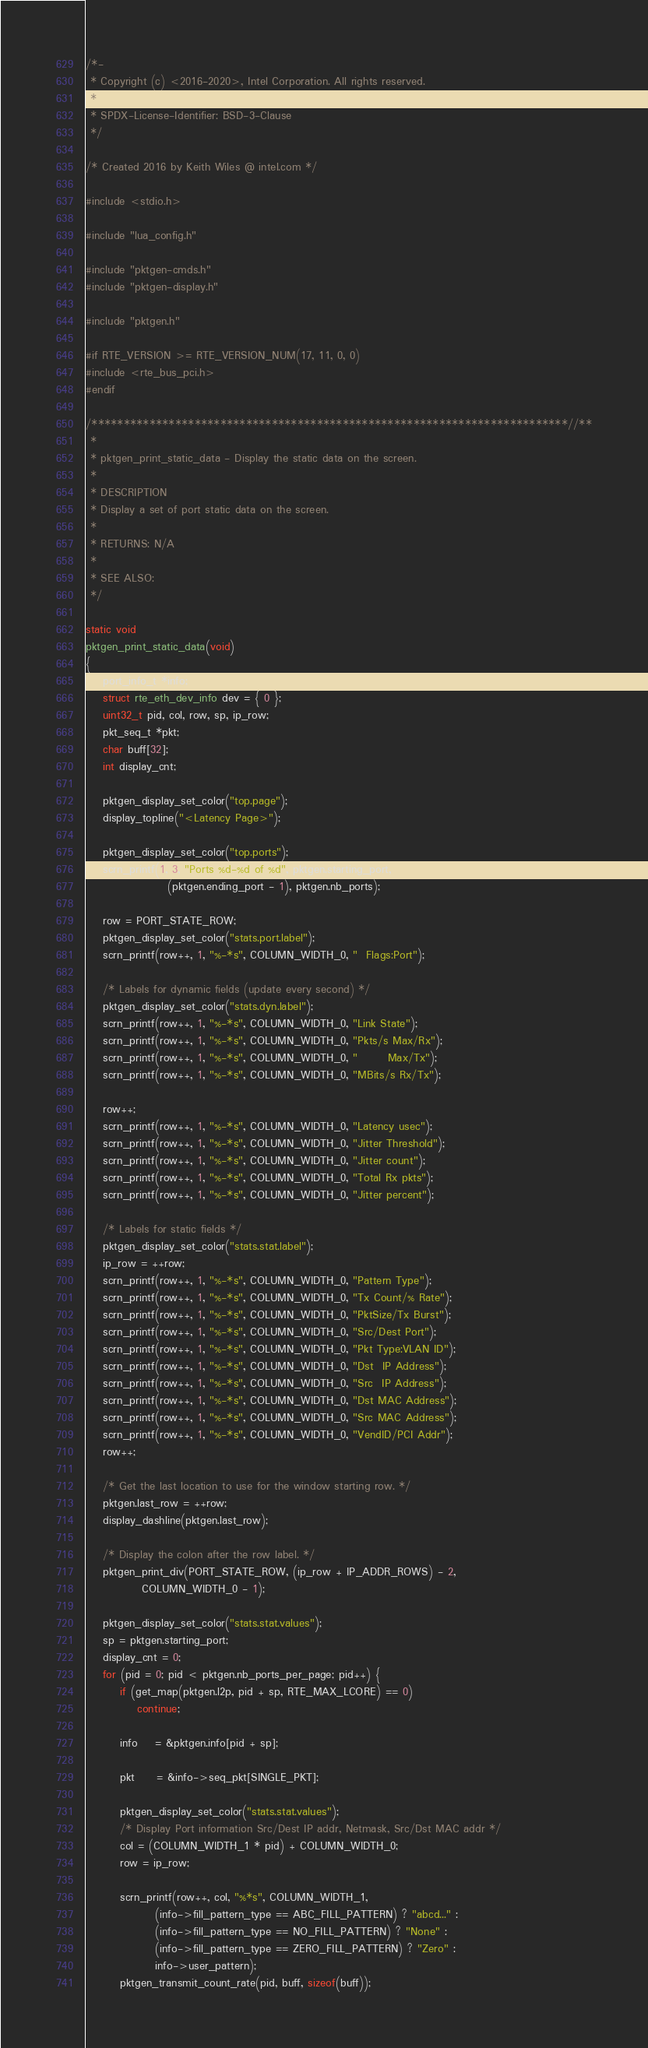<code> <loc_0><loc_0><loc_500><loc_500><_C_>/*-
 * Copyright (c) <2016-2020>, Intel Corporation. All rights reserved.
 *
 * SPDX-License-Identifier: BSD-3-Clause
 */

/* Created 2016 by Keith Wiles @ intel.com */

#include <stdio.h>

#include "lua_config.h"

#include "pktgen-cmds.h"
#include "pktgen-display.h"

#include "pktgen.h"

#if RTE_VERSION >= RTE_VERSION_NUM(17, 11, 0, 0)
#include <rte_bus_pci.h>
#endif

/**************************************************************************//**
 *
 * pktgen_print_static_data - Display the static data on the screen.
 *
 * DESCRIPTION
 * Display a set of port static data on the screen.
 *
 * RETURNS: N/A
 *
 * SEE ALSO:
 */

static void
pktgen_print_static_data(void)
{
	port_info_t *info;
	struct rte_eth_dev_info dev = { 0 };
	uint32_t pid, col, row, sp, ip_row;
	pkt_seq_t *pkt;
	char buff[32];
	int display_cnt;

	pktgen_display_set_color("top.page");
	display_topline("<Latency Page>");

	pktgen_display_set_color("top.ports");
	scrn_printf(1, 3, "Ports %d-%d of %d", pktgen.starting_port,
	               (pktgen.ending_port - 1), pktgen.nb_ports);

	row = PORT_STATE_ROW;
	pktgen_display_set_color("stats.port.label");
	scrn_printf(row++, 1, "%-*s", COLUMN_WIDTH_0, "  Flags:Port");

	/* Labels for dynamic fields (update every second) */
	pktgen_display_set_color("stats.dyn.label");
	scrn_printf(row++, 1, "%-*s", COLUMN_WIDTH_0, "Link State");
	scrn_printf(row++, 1, "%-*s", COLUMN_WIDTH_0, "Pkts/s Max/Rx");
	scrn_printf(row++, 1, "%-*s", COLUMN_WIDTH_0, "       Max/Tx");
	scrn_printf(row++, 1, "%-*s", COLUMN_WIDTH_0, "MBits/s Rx/Tx");

	row++;
	scrn_printf(row++, 1, "%-*s", COLUMN_WIDTH_0, "Latency usec");
	scrn_printf(row++, 1, "%-*s", COLUMN_WIDTH_0, "Jitter Threshold");
	scrn_printf(row++, 1, "%-*s", COLUMN_WIDTH_0, "Jitter count");
	scrn_printf(row++, 1, "%-*s", COLUMN_WIDTH_0, "Total Rx pkts");
	scrn_printf(row++, 1, "%-*s", COLUMN_WIDTH_0, "Jitter percent");

	/* Labels for static fields */
	pktgen_display_set_color("stats.stat.label");
	ip_row = ++row;
	scrn_printf(row++, 1, "%-*s", COLUMN_WIDTH_0, "Pattern Type");
	scrn_printf(row++, 1, "%-*s", COLUMN_WIDTH_0, "Tx Count/% Rate");
	scrn_printf(row++, 1, "%-*s", COLUMN_WIDTH_0, "PktSize/Tx Burst");
	scrn_printf(row++, 1, "%-*s", COLUMN_WIDTH_0, "Src/Dest Port");
	scrn_printf(row++, 1, "%-*s", COLUMN_WIDTH_0, "Pkt Type:VLAN ID");
	scrn_printf(row++, 1, "%-*s", COLUMN_WIDTH_0, "Dst  IP Address");
	scrn_printf(row++, 1, "%-*s", COLUMN_WIDTH_0, "Src  IP Address");
	scrn_printf(row++, 1, "%-*s", COLUMN_WIDTH_0, "Dst MAC Address");
	scrn_printf(row++, 1, "%-*s", COLUMN_WIDTH_0, "Src MAC Address");
	scrn_printf(row++, 1, "%-*s", COLUMN_WIDTH_0, "VendID/PCI Addr");
	row++;

	/* Get the last location to use for the window starting row. */
	pktgen.last_row = ++row;
	display_dashline(pktgen.last_row);

	/* Display the colon after the row label. */
	pktgen_print_div(PORT_STATE_ROW, (ip_row + IP_ADDR_ROWS) - 2,
			 COLUMN_WIDTH_0 - 1);

	pktgen_display_set_color("stats.stat.values");
	sp = pktgen.starting_port;
	display_cnt = 0;
	for (pid = 0; pid < pktgen.nb_ports_per_page; pid++) {
		if (get_map(pktgen.l2p, pid + sp, RTE_MAX_LCORE) == 0)
			continue;

		info    = &pktgen.info[pid + sp];

		pkt     = &info->seq_pkt[SINGLE_PKT];

		pktgen_display_set_color("stats.stat.values");
		/* Display Port information Src/Dest IP addr, Netmask, Src/Dst MAC addr */
		col = (COLUMN_WIDTH_1 * pid) + COLUMN_WIDTH_0;
		row = ip_row;

		scrn_printf(row++, col, "%*s", COLUMN_WIDTH_1,
		        (info->fill_pattern_type == ABC_FILL_PATTERN) ? "abcd..." :
		        (info->fill_pattern_type == NO_FILL_PATTERN) ? "None" :
		        (info->fill_pattern_type == ZERO_FILL_PATTERN) ? "Zero" :
		        info->user_pattern);
		pktgen_transmit_count_rate(pid, buff, sizeof(buff));</code> 